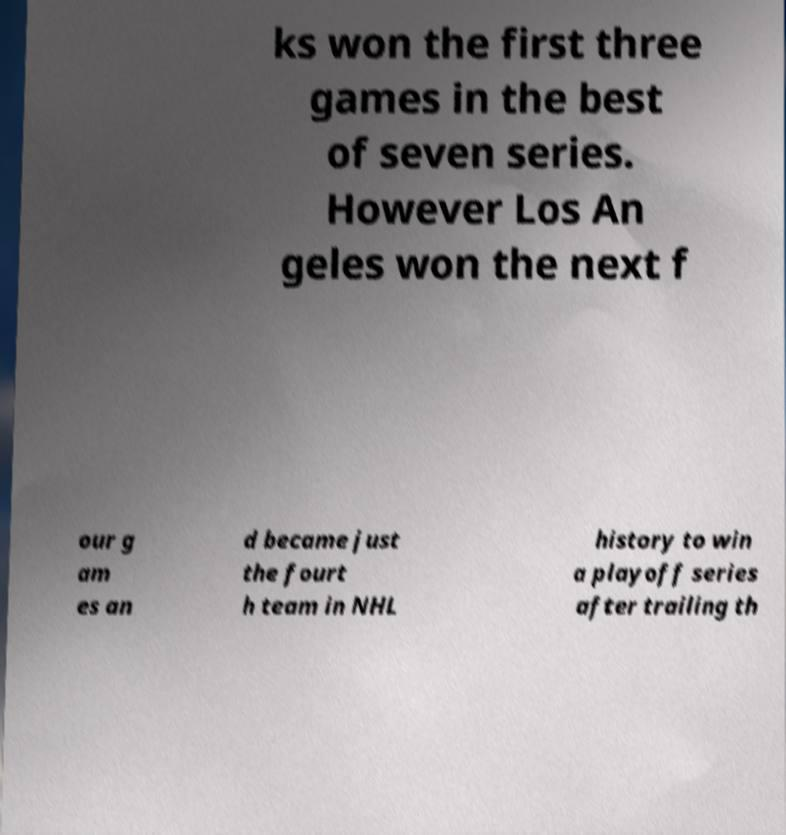Could you assist in decoding the text presented in this image and type it out clearly? ks won the first three games in the best of seven series. However Los An geles won the next f our g am es an d became just the fourt h team in NHL history to win a playoff series after trailing th 